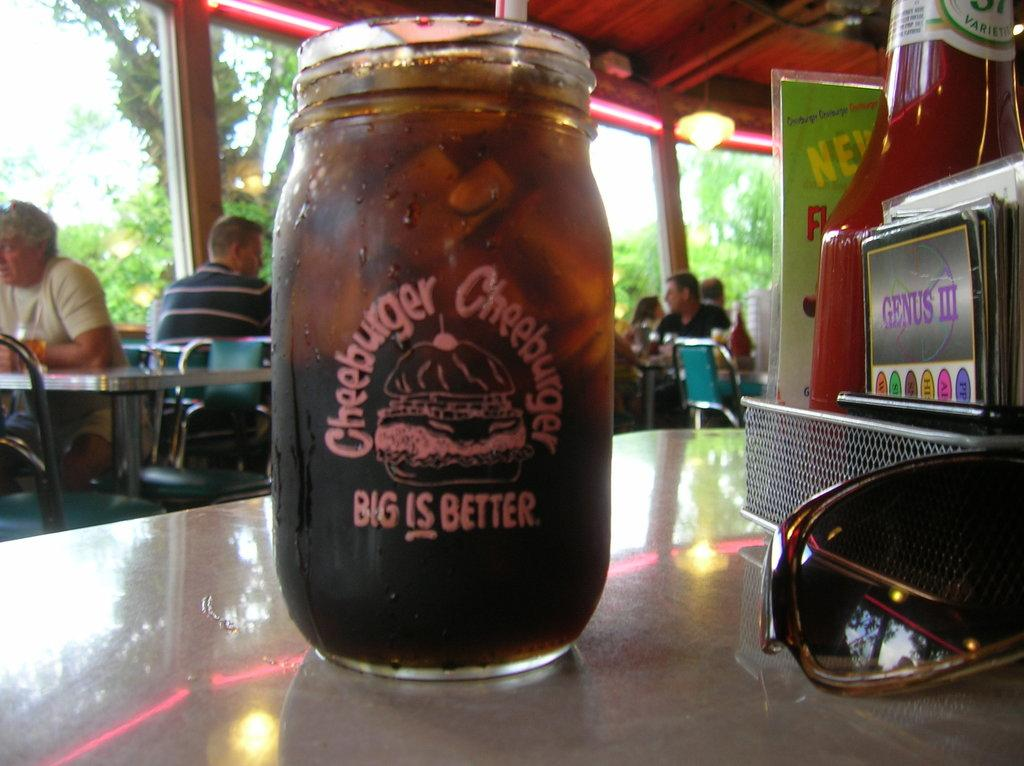What type of plant can be seen in the image? There is a tree in the image. What are the people in the image doing? The people are sitting on chairs in the image. What piece of furniture is present in the image? There is a table in the image. What items can be seen on the table in the image? There is a bottle and a pair of goggles on the table in the image. Can you tell me how many beginner swimmers are in the lake in the image? There is no lake or beginner swimmers present in the image. What color is the nose of the person sitting on the chair in the image? There is no mention of a person's nose in the image, and we cannot determine its color based on the provided facts. 